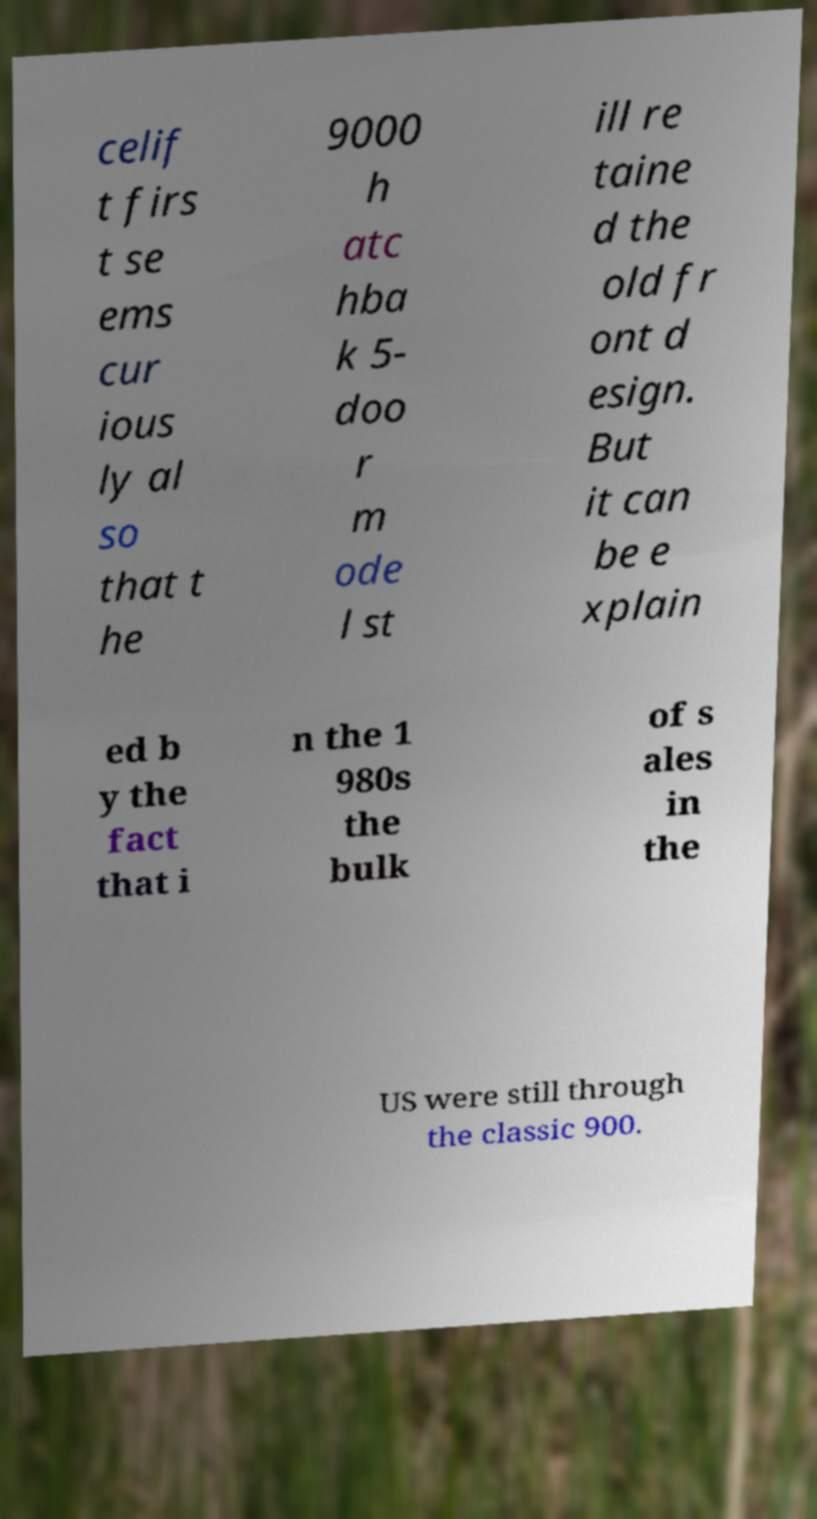For documentation purposes, I need the text within this image transcribed. Could you provide that? celif t firs t se ems cur ious ly al so that t he 9000 h atc hba k 5- doo r m ode l st ill re taine d the old fr ont d esign. But it can be e xplain ed b y the fact that i n the 1 980s the bulk of s ales in the US were still through the classic 900. 